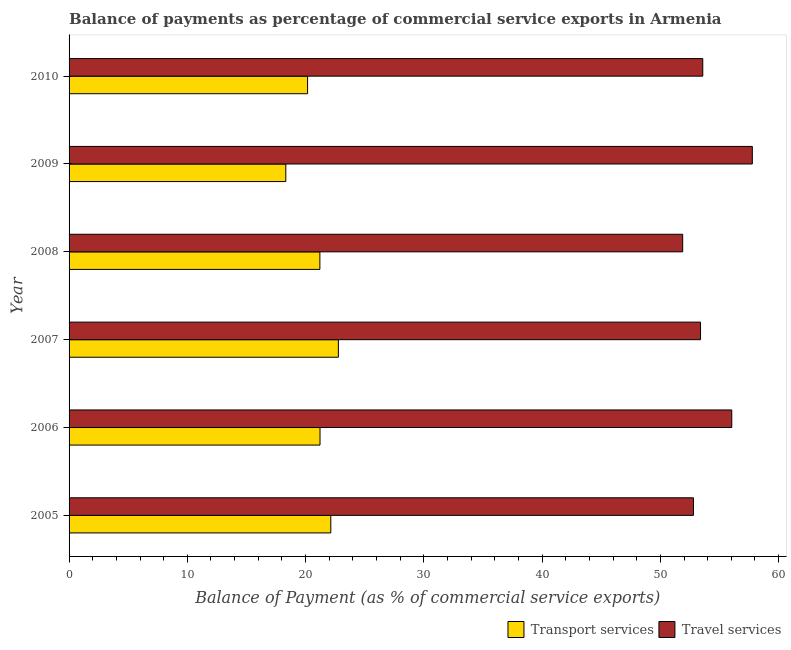How many groups of bars are there?
Offer a very short reply. 6. How many bars are there on the 2nd tick from the top?
Ensure brevity in your answer.  2. What is the balance of payments of travel services in 2009?
Your answer should be very brief. 57.78. Across all years, what is the maximum balance of payments of transport services?
Provide a succinct answer. 22.77. Across all years, what is the minimum balance of payments of travel services?
Give a very brief answer. 51.89. In which year was the balance of payments of transport services minimum?
Provide a succinct answer. 2009. What is the total balance of payments of transport services in the graph?
Provide a short and direct response. 125.83. What is the difference between the balance of payments of travel services in 2008 and that in 2009?
Your answer should be very brief. -5.89. What is the difference between the balance of payments of travel services in 2008 and the balance of payments of transport services in 2005?
Make the answer very short. 29.76. What is the average balance of payments of travel services per year?
Keep it short and to the point. 54.25. In the year 2010, what is the difference between the balance of payments of travel services and balance of payments of transport services?
Offer a terse response. 33.42. What is the difference between the highest and the second highest balance of payments of travel services?
Make the answer very short. 1.74. What is the difference between the highest and the lowest balance of payments of travel services?
Give a very brief answer. 5.89. In how many years, is the balance of payments of travel services greater than the average balance of payments of travel services taken over all years?
Keep it short and to the point. 2. What does the 2nd bar from the top in 2007 represents?
Ensure brevity in your answer.  Transport services. What does the 2nd bar from the bottom in 2010 represents?
Offer a very short reply. Travel services. How many bars are there?
Ensure brevity in your answer.  12. Are all the bars in the graph horizontal?
Provide a succinct answer. Yes. What is the difference between two consecutive major ticks on the X-axis?
Keep it short and to the point. 10. Are the values on the major ticks of X-axis written in scientific E-notation?
Provide a short and direct response. No. Does the graph contain grids?
Provide a succinct answer. No. How many legend labels are there?
Keep it short and to the point. 2. How are the legend labels stacked?
Ensure brevity in your answer.  Horizontal. What is the title of the graph?
Your response must be concise. Balance of payments as percentage of commercial service exports in Armenia. Does "Official aid received" appear as one of the legend labels in the graph?
Offer a terse response. No. What is the label or title of the X-axis?
Your answer should be very brief. Balance of Payment (as % of commercial service exports). What is the Balance of Payment (as % of commercial service exports) in Transport services in 2005?
Offer a terse response. 22.13. What is the Balance of Payment (as % of commercial service exports) of Travel services in 2005?
Your answer should be very brief. 52.8. What is the Balance of Payment (as % of commercial service exports) of Transport services in 2006?
Provide a short and direct response. 21.22. What is the Balance of Payment (as % of commercial service exports) in Travel services in 2006?
Provide a succinct answer. 56.04. What is the Balance of Payment (as % of commercial service exports) in Transport services in 2007?
Ensure brevity in your answer.  22.77. What is the Balance of Payment (as % of commercial service exports) of Travel services in 2007?
Your answer should be very brief. 53.4. What is the Balance of Payment (as % of commercial service exports) of Transport services in 2008?
Your response must be concise. 21.21. What is the Balance of Payment (as % of commercial service exports) of Travel services in 2008?
Make the answer very short. 51.89. What is the Balance of Payment (as % of commercial service exports) in Transport services in 2009?
Give a very brief answer. 18.33. What is the Balance of Payment (as % of commercial service exports) of Travel services in 2009?
Give a very brief answer. 57.78. What is the Balance of Payment (as % of commercial service exports) in Transport services in 2010?
Keep it short and to the point. 20.17. What is the Balance of Payment (as % of commercial service exports) in Travel services in 2010?
Keep it short and to the point. 53.59. Across all years, what is the maximum Balance of Payment (as % of commercial service exports) in Transport services?
Your answer should be compact. 22.77. Across all years, what is the maximum Balance of Payment (as % of commercial service exports) in Travel services?
Provide a succinct answer. 57.78. Across all years, what is the minimum Balance of Payment (as % of commercial service exports) in Transport services?
Provide a succinct answer. 18.33. Across all years, what is the minimum Balance of Payment (as % of commercial service exports) in Travel services?
Keep it short and to the point. 51.89. What is the total Balance of Payment (as % of commercial service exports) in Transport services in the graph?
Give a very brief answer. 125.83. What is the total Balance of Payment (as % of commercial service exports) in Travel services in the graph?
Ensure brevity in your answer.  325.5. What is the difference between the Balance of Payment (as % of commercial service exports) in Transport services in 2005 and that in 2006?
Offer a terse response. 0.91. What is the difference between the Balance of Payment (as % of commercial service exports) of Travel services in 2005 and that in 2006?
Your response must be concise. -3.24. What is the difference between the Balance of Payment (as % of commercial service exports) of Transport services in 2005 and that in 2007?
Make the answer very short. -0.64. What is the difference between the Balance of Payment (as % of commercial service exports) in Travel services in 2005 and that in 2007?
Ensure brevity in your answer.  -0.6. What is the difference between the Balance of Payment (as % of commercial service exports) in Transport services in 2005 and that in 2008?
Provide a succinct answer. 0.92. What is the difference between the Balance of Payment (as % of commercial service exports) of Travel services in 2005 and that in 2008?
Provide a short and direct response. 0.91. What is the difference between the Balance of Payment (as % of commercial service exports) of Transport services in 2005 and that in 2009?
Give a very brief answer. 3.81. What is the difference between the Balance of Payment (as % of commercial service exports) of Travel services in 2005 and that in 2009?
Your response must be concise. -4.98. What is the difference between the Balance of Payment (as % of commercial service exports) in Transport services in 2005 and that in 2010?
Keep it short and to the point. 1.96. What is the difference between the Balance of Payment (as % of commercial service exports) in Travel services in 2005 and that in 2010?
Your answer should be compact. -0.79. What is the difference between the Balance of Payment (as % of commercial service exports) of Transport services in 2006 and that in 2007?
Offer a terse response. -1.55. What is the difference between the Balance of Payment (as % of commercial service exports) in Travel services in 2006 and that in 2007?
Your answer should be very brief. 2.64. What is the difference between the Balance of Payment (as % of commercial service exports) of Transport services in 2006 and that in 2008?
Your response must be concise. 0.01. What is the difference between the Balance of Payment (as % of commercial service exports) in Travel services in 2006 and that in 2008?
Give a very brief answer. 4.15. What is the difference between the Balance of Payment (as % of commercial service exports) in Transport services in 2006 and that in 2009?
Keep it short and to the point. 2.89. What is the difference between the Balance of Payment (as % of commercial service exports) of Travel services in 2006 and that in 2009?
Provide a succinct answer. -1.74. What is the difference between the Balance of Payment (as % of commercial service exports) of Transport services in 2006 and that in 2010?
Your answer should be compact. 1.05. What is the difference between the Balance of Payment (as % of commercial service exports) of Travel services in 2006 and that in 2010?
Your answer should be very brief. 2.45. What is the difference between the Balance of Payment (as % of commercial service exports) in Transport services in 2007 and that in 2008?
Make the answer very short. 1.56. What is the difference between the Balance of Payment (as % of commercial service exports) of Travel services in 2007 and that in 2008?
Your answer should be very brief. 1.51. What is the difference between the Balance of Payment (as % of commercial service exports) in Transport services in 2007 and that in 2009?
Provide a succinct answer. 4.45. What is the difference between the Balance of Payment (as % of commercial service exports) of Travel services in 2007 and that in 2009?
Offer a very short reply. -4.38. What is the difference between the Balance of Payment (as % of commercial service exports) in Transport services in 2007 and that in 2010?
Your answer should be compact. 2.6. What is the difference between the Balance of Payment (as % of commercial service exports) of Travel services in 2007 and that in 2010?
Offer a very short reply. -0.19. What is the difference between the Balance of Payment (as % of commercial service exports) of Transport services in 2008 and that in 2009?
Provide a short and direct response. 2.88. What is the difference between the Balance of Payment (as % of commercial service exports) of Travel services in 2008 and that in 2009?
Offer a very short reply. -5.89. What is the difference between the Balance of Payment (as % of commercial service exports) in Transport services in 2008 and that in 2010?
Provide a succinct answer. 1.04. What is the difference between the Balance of Payment (as % of commercial service exports) in Travel services in 2008 and that in 2010?
Ensure brevity in your answer.  -1.7. What is the difference between the Balance of Payment (as % of commercial service exports) in Transport services in 2009 and that in 2010?
Your response must be concise. -1.84. What is the difference between the Balance of Payment (as % of commercial service exports) of Travel services in 2009 and that in 2010?
Your answer should be compact. 4.19. What is the difference between the Balance of Payment (as % of commercial service exports) in Transport services in 2005 and the Balance of Payment (as % of commercial service exports) in Travel services in 2006?
Keep it short and to the point. -33.91. What is the difference between the Balance of Payment (as % of commercial service exports) of Transport services in 2005 and the Balance of Payment (as % of commercial service exports) of Travel services in 2007?
Provide a succinct answer. -31.27. What is the difference between the Balance of Payment (as % of commercial service exports) in Transport services in 2005 and the Balance of Payment (as % of commercial service exports) in Travel services in 2008?
Keep it short and to the point. -29.76. What is the difference between the Balance of Payment (as % of commercial service exports) in Transport services in 2005 and the Balance of Payment (as % of commercial service exports) in Travel services in 2009?
Your answer should be very brief. -35.65. What is the difference between the Balance of Payment (as % of commercial service exports) of Transport services in 2005 and the Balance of Payment (as % of commercial service exports) of Travel services in 2010?
Provide a succinct answer. -31.46. What is the difference between the Balance of Payment (as % of commercial service exports) in Transport services in 2006 and the Balance of Payment (as % of commercial service exports) in Travel services in 2007?
Your answer should be very brief. -32.18. What is the difference between the Balance of Payment (as % of commercial service exports) of Transport services in 2006 and the Balance of Payment (as % of commercial service exports) of Travel services in 2008?
Offer a very short reply. -30.67. What is the difference between the Balance of Payment (as % of commercial service exports) of Transport services in 2006 and the Balance of Payment (as % of commercial service exports) of Travel services in 2009?
Give a very brief answer. -36.56. What is the difference between the Balance of Payment (as % of commercial service exports) in Transport services in 2006 and the Balance of Payment (as % of commercial service exports) in Travel services in 2010?
Your answer should be compact. -32.37. What is the difference between the Balance of Payment (as % of commercial service exports) in Transport services in 2007 and the Balance of Payment (as % of commercial service exports) in Travel services in 2008?
Provide a succinct answer. -29.12. What is the difference between the Balance of Payment (as % of commercial service exports) of Transport services in 2007 and the Balance of Payment (as % of commercial service exports) of Travel services in 2009?
Keep it short and to the point. -35.01. What is the difference between the Balance of Payment (as % of commercial service exports) of Transport services in 2007 and the Balance of Payment (as % of commercial service exports) of Travel services in 2010?
Keep it short and to the point. -30.81. What is the difference between the Balance of Payment (as % of commercial service exports) of Transport services in 2008 and the Balance of Payment (as % of commercial service exports) of Travel services in 2009?
Offer a terse response. -36.57. What is the difference between the Balance of Payment (as % of commercial service exports) in Transport services in 2008 and the Balance of Payment (as % of commercial service exports) in Travel services in 2010?
Ensure brevity in your answer.  -32.38. What is the difference between the Balance of Payment (as % of commercial service exports) of Transport services in 2009 and the Balance of Payment (as % of commercial service exports) of Travel services in 2010?
Ensure brevity in your answer.  -35.26. What is the average Balance of Payment (as % of commercial service exports) in Transport services per year?
Make the answer very short. 20.97. What is the average Balance of Payment (as % of commercial service exports) in Travel services per year?
Your answer should be very brief. 54.25. In the year 2005, what is the difference between the Balance of Payment (as % of commercial service exports) in Transport services and Balance of Payment (as % of commercial service exports) in Travel services?
Your answer should be compact. -30.67. In the year 2006, what is the difference between the Balance of Payment (as % of commercial service exports) in Transport services and Balance of Payment (as % of commercial service exports) in Travel services?
Provide a short and direct response. -34.82. In the year 2007, what is the difference between the Balance of Payment (as % of commercial service exports) of Transport services and Balance of Payment (as % of commercial service exports) of Travel services?
Your answer should be very brief. -30.62. In the year 2008, what is the difference between the Balance of Payment (as % of commercial service exports) of Transport services and Balance of Payment (as % of commercial service exports) of Travel services?
Your answer should be compact. -30.68. In the year 2009, what is the difference between the Balance of Payment (as % of commercial service exports) of Transport services and Balance of Payment (as % of commercial service exports) of Travel services?
Ensure brevity in your answer.  -39.45. In the year 2010, what is the difference between the Balance of Payment (as % of commercial service exports) of Transport services and Balance of Payment (as % of commercial service exports) of Travel services?
Make the answer very short. -33.42. What is the ratio of the Balance of Payment (as % of commercial service exports) in Transport services in 2005 to that in 2006?
Your answer should be very brief. 1.04. What is the ratio of the Balance of Payment (as % of commercial service exports) of Travel services in 2005 to that in 2006?
Give a very brief answer. 0.94. What is the ratio of the Balance of Payment (as % of commercial service exports) of Transport services in 2005 to that in 2007?
Your answer should be very brief. 0.97. What is the ratio of the Balance of Payment (as % of commercial service exports) in Travel services in 2005 to that in 2007?
Offer a terse response. 0.99. What is the ratio of the Balance of Payment (as % of commercial service exports) in Transport services in 2005 to that in 2008?
Your answer should be very brief. 1.04. What is the ratio of the Balance of Payment (as % of commercial service exports) of Travel services in 2005 to that in 2008?
Make the answer very short. 1.02. What is the ratio of the Balance of Payment (as % of commercial service exports) of Transport services in 2005 to that in 2009?
Give a very brief answer. 1.21. What is the ratio of the Balance of Payment (as % of commercial service exports) in Travel services in 2005 to that in 2009?
Provide a succinct answer. 0.91. What is the ratio of the Balance of Payment (as % of commercial service exports) of Transport services in 2005 to that in 2010?
Make the answer very short. 1.1. What is the ratio of the Balance of Payment (as % of commercial service exports) of Transport services in 2006 to that in 2007?
Your response must be concise. 0.93. What is the ratio of the Balance of Payment (as % of commercial service exports) of Travel services in 2006 to that in 2007?
Provide a succinct answer. 1.05. What is the ratio of the Balance of Payment (as % of commercial service exports) of Transport services in 2006 to that in 2008?
Offer a very short reply. 1. What is the ratio of the Balance of Payment (as % of commercial service exports) of Travel services in 2006 to that in 2008?
Keep it short and to the point. 1.08. What is the ratio of the Balance of Payment (as % of commercial service exports) in Transport services in 2006 to that in 2009?
Offer a very short reply. 1.16. What is the ratio of the Balance of Payment (as % of commercial service exports) in Travel services in 2006 to that in 2009?
Your answer should be very brief. 0.97. What is the ratio of the Balance of Payment (as % of commercial service exports) of Transport services in 2006 to that in 2010?
Provide a short and direct response. 1.05. What is the ratio of the Balance of Payment (as % of commercial service exports) of Travel services in 2006 to that in 2010?
Your response must be concise. 1.05. What is the ratio of the Balance of Payment (as % of commercial service exports) in Transport services in 2007 to that in 2008?
Your response must be concise. 1.07. What is the ratio of the Balance of Payment (as % of commercial service exports) in Travel services in 2007 to that in 2008?
Your answer should be compact. 1.03. What is the ratio of the Balance of Payment (as % of commercial service exports) in Transport services in 2007 to that in 2009?
Provide a succinct answer. 1.24. What is the ratio of the Balance of Payment (as % of commercial service exports) of Travel services in 2007 to that in 2009?
Your answer should be compact. 0.92. What is the ratio of the Balance of Payment (as % of commercial service exports) of Transport services in 2007 to that in 2010?
Ensure brevity in your answer.  1.13. What is the ratio of the Balance of Payment (as % of commercial service exports) in Transport services in 2008 to that in 2009?
Give a very brief answer. 1.16. What is the ratio of the Balance of Payment (as % of commercial service exports) of Travel services in 2008 to that in 2009?
Give a very brief answer. 0.9. What is the ratio of the Balance of Payment (as % of commercial service exports) of Transport services in 2008 to that in 2010?
Your answer should be very brief. 1.05. What is the ratio of the Balance of Payment (as % of commercial service exports) of Travel services in 2008 to that in 2010?
Provide a short and direct response. 0.97. What is the ratio of the Balance of Payment (as % of commercial service exports) of Transport services in 2009 to that in 2010?
Offer a terse response. 0.91. What is the ratio of the Balance of Payment (as % of commercial service exports) of Travel services in 2009 to that in 2010?
Offer a very short reply. 1.08. What is the difference between the highest and the second highest Balance of Payment (as % of commercial service exports) of Transport services?
Offer a very short reply. 0.64. What is the difference between the highest and the second highest Balance of Payment (as % of commercial service exports) of Travel services?
Provide a short and direct response. 1.74. What is the difference between the highest and the lowest Balance of Payment (as % of commercial service exports) in Transport services?
Your response must be concise. 4.45. What is the difference between the highest and the lowest Balance of Payment (as % of commercial service exports) in Travel services?
Offer a terse response. 5.89. 